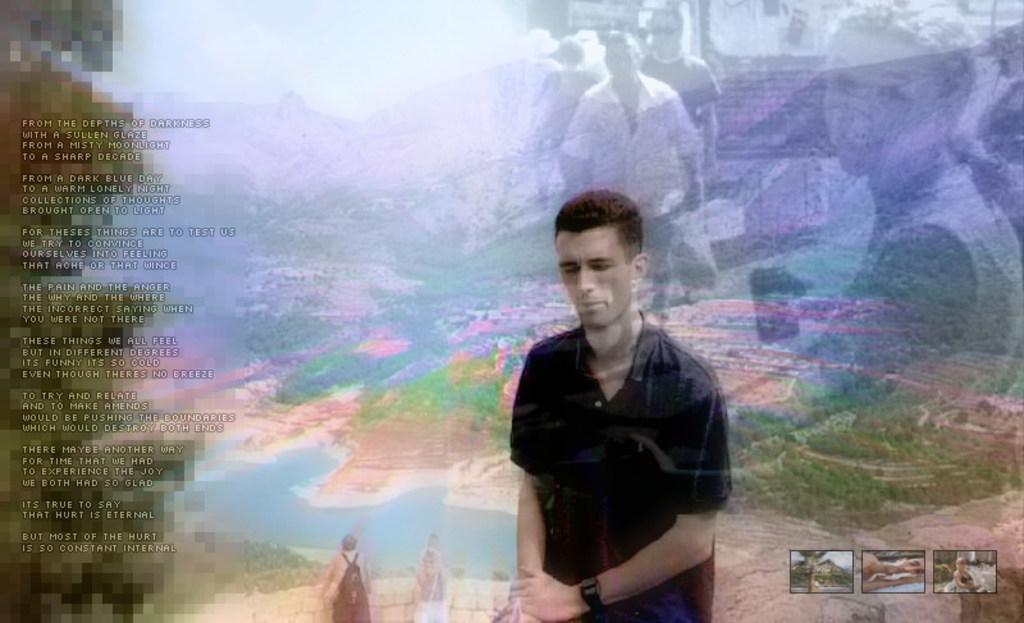Please provide a concise description of this image. This picture is an edited picture. on the left side of the image there is a text. In the middle of the image there are group of people. At the back there are group of people and there are mountains. At the bottom there is water and there are trees. At the bottom right there are pictures. 